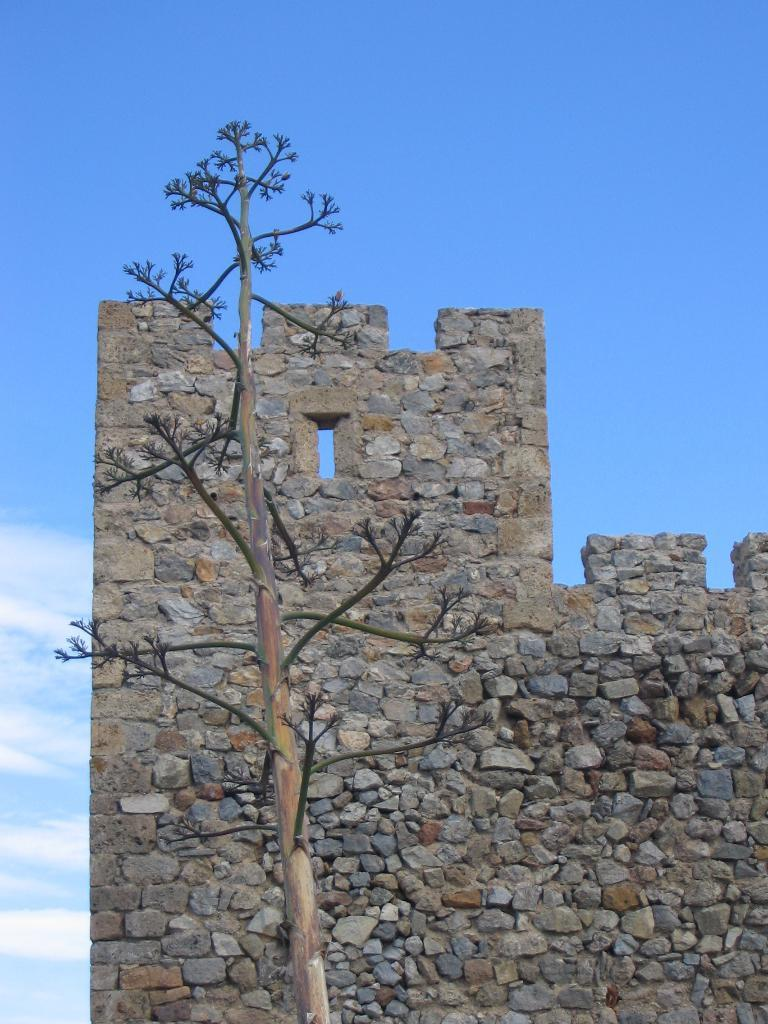What type of structure is present in the image? There is a stone wall in the image. What natural element can be seen in the image? There is a tree in the image. How would you describe the sky in the image? The sky is blue and cloudy in the image. Can you tell me which ear is visible in the image? There are no ears present in the image; it features a stone wall, a tree, and a blue and cloudy sky. What type of dental procedure is being performed in the image? There is no dental procedure or tooth present in the image. 